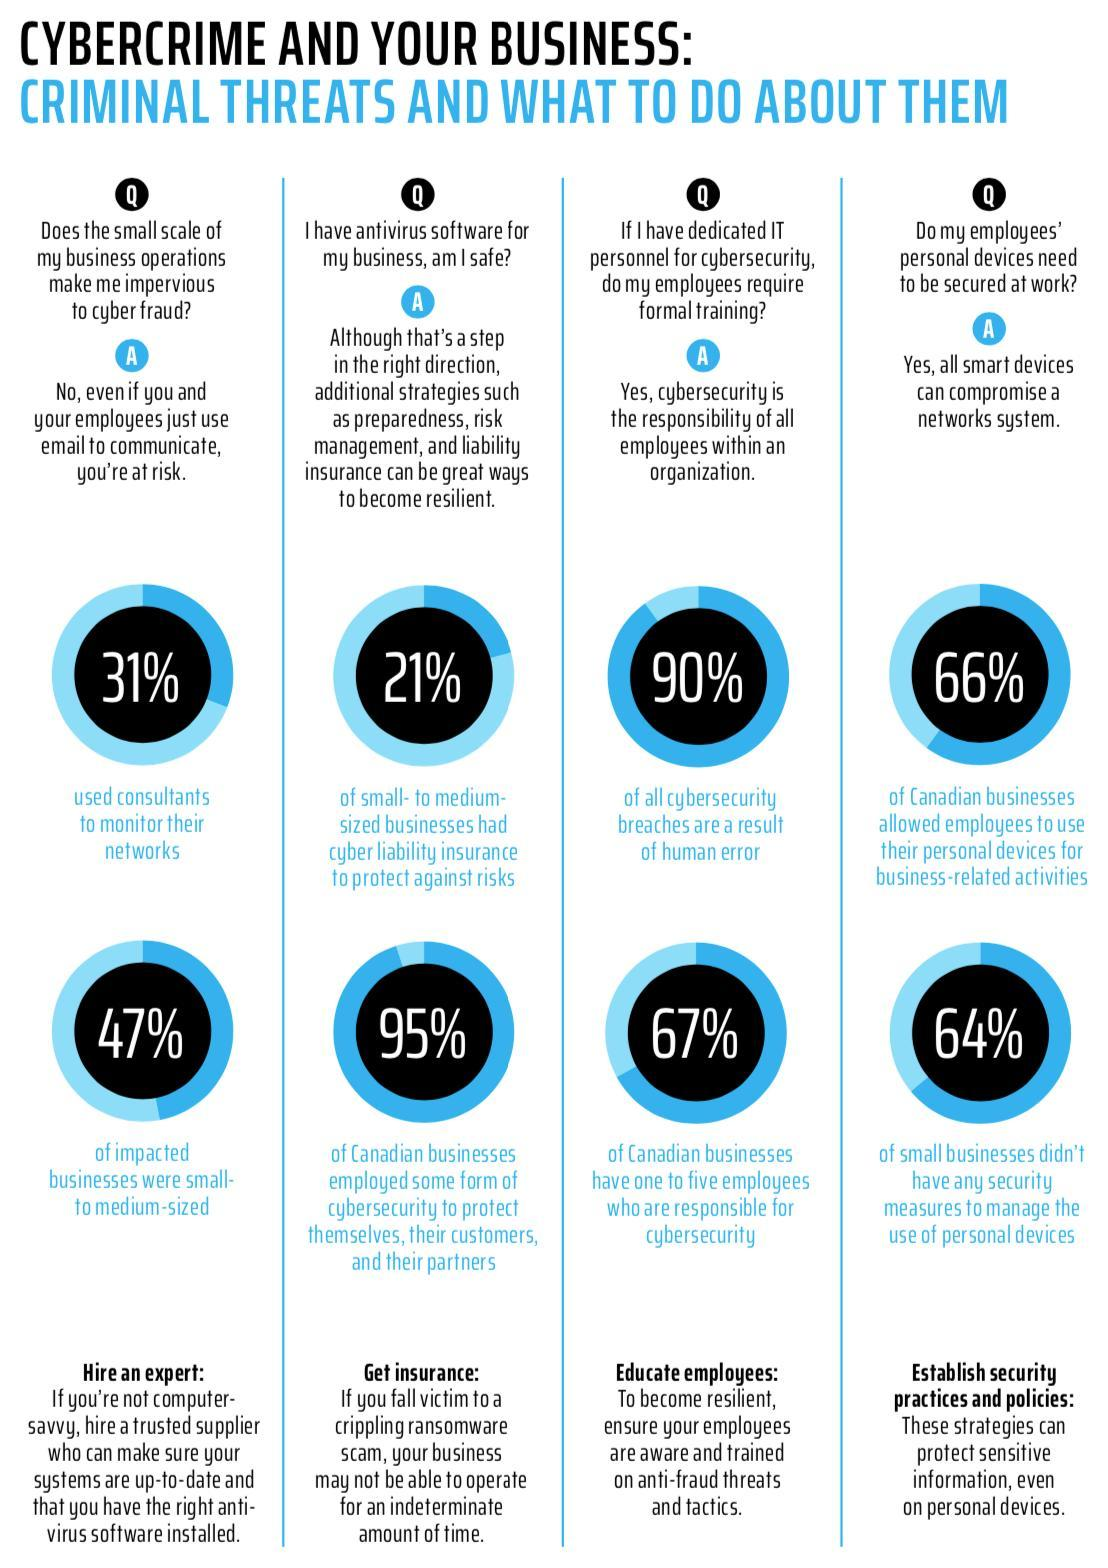What percentage of Canadian businesses have already deployed internet security measures?
Answer the question with a short phrase. 95% What percentage of businesses have not deployed any security measures to deal with individual gadgets? 64% What percentage of companies have insurance to prevent internet risks? 21% What percentage of companies affected with internet security are small-to medium-sized? 47% What percentage of companies affected with internet security are not small-to medium-sized? 53 What percentage of Canadian businesses have not deployed any internet security measures? 5 What percentage of Canadian businesses have granted permission to employees to work with their own devices? 66% How many workers will be there in a company to take care of internet security? one to five What is the inverse percentage of businesses with insurance to prevent internet risks? 79 What percentage of Internet security violations are due to manual mistakes? 90% 